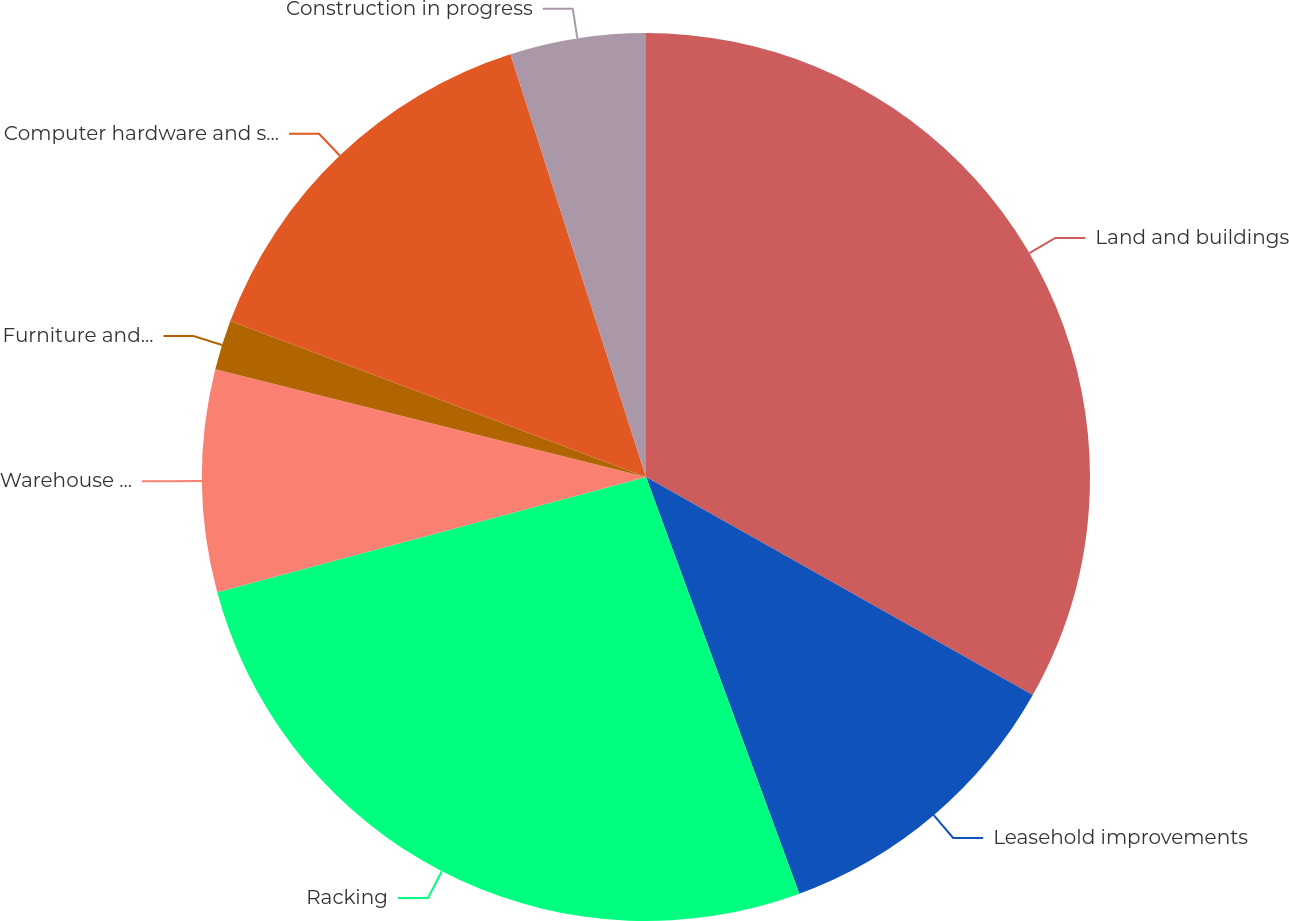Convert chart. <chart><loc_0><loc_0><loc_500><loc_500><pie_chart><fcel>Land and buildings<fcel>Leasehold improvements<fcel>Racking<fcel>Warehouse equipment/vehicles<fcel>Furniture and fixtures<fcel>Computer hardware and software<fcel>Construction in progress<nl><fcel>33.17%<fcel>11.22%<fcel>26.43%<fcel>8.08%<fcel>1.81%<fcel>14.35%<fcel>4.94%<nl></chart> 